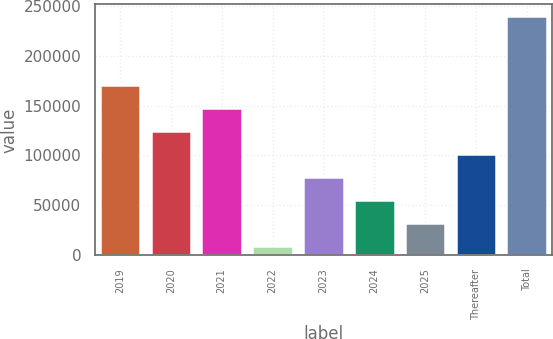Convert chart to OTSL. <chart><loc_0><loc_0><loc_500><loc_500><bar_chart><fcel>2019<fcel>2020<fcel>2021<fcel>2022<fcel>2023<fcel>2024<fcel>2025<fcel>Thereafter<fcel>Total<nl><fcel>170267<fcel>124256<fcel>147262<fcel>9231<fcel>78246.3<fcel>55241.2<fcel>32236.1<fcel>101251<fcel>239282<nl></chart> 